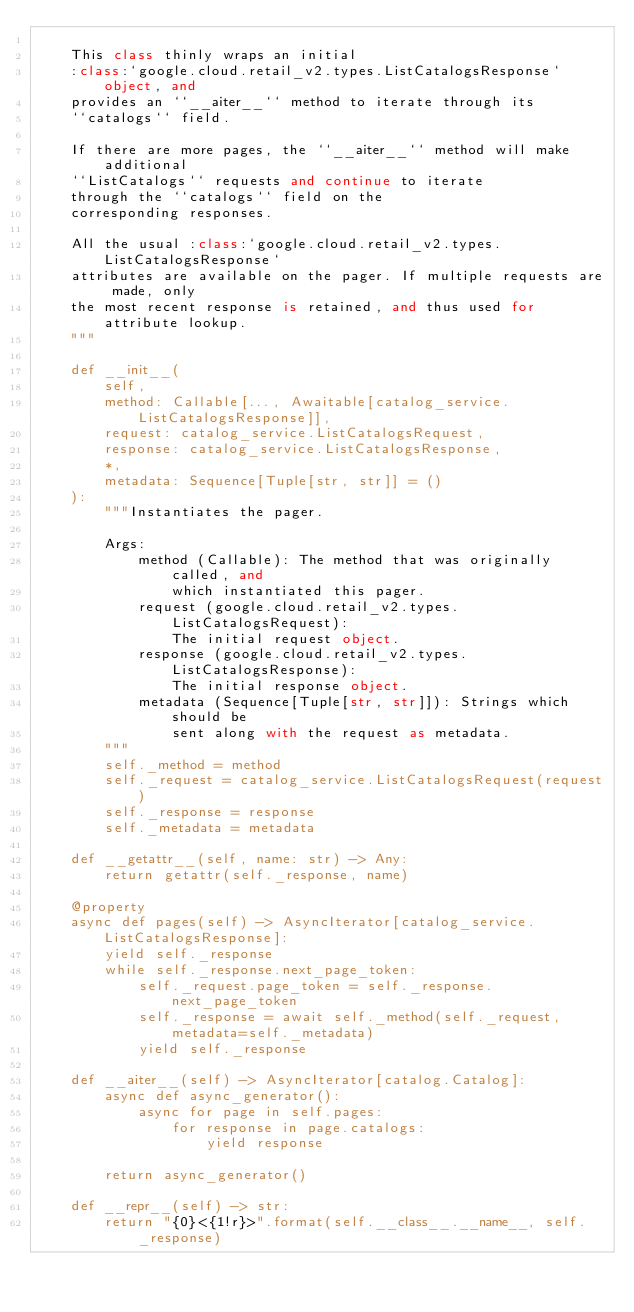<code> <loc_0><loc_0><loc_500><loc_500><_Python_>
    This class thinly wraps an initial
    :class:`google.cloud.retail_v2.types.ListCatalogsResponse` object, and
    provides an ``__aiter__`` method to iterate through its
    ``catalogs`` field.

    If there are more pages, the ``__aiter__`` method will make additional
    ``ListCatalogs`` requests and continue to iterate
    through the ``catalogs`` field on the
    corresponding responses.

    All the usual :class:`google.cloud.retail_v2.types.ListCatalogsResponse`
    attributes are available on the pager. If multiple requests are made, only
    the most recent response is retained, and thus used for attribute lookup.
    """

    def __init__(
        self,
        method: Callable[..., Awaitable[catalog_service.ListCatalogsResponse]],
        request: catalog_service.ListCatalogsRequest,
        response: catalog_service.ListCatalogsResponse,
        *,
        metadata: Sequence[Tuple[str, str]] = ()
    ):
        """Instantiates the pager.

        Args:
            method (Callable): The method that was originally called, and
                which instantiated this pager.
            request (google.cloud.retail_v2.types.ListCatalogsRequest):
                The initial request object.
            response (google.cloud.retail_v2.types.ListCatalogsResponse):
                The initial response object.
            metadata (Sequence[Tuple[str, str]]): Strings which should be
                sent along with the request as metadata.
        """
        self._method = method
        self._request = catalog_service.ListCatalogsRequest(request)
        self._response = response
        self._metadata = metadata

    def __getattr__(self, name: str) -> Any:
        return getattr(self._response, name)

    @property
    async def pages(self) -> AsyncIterator[catalog_service.ListCatalogsResponse]:
        yield self._response
        while self._response.next_page_token:
            self._request.page_token = self._response.next_page_token
            self._response = await self._method(self._request, metadata=self._metadata)
            yield self._response

    def __aiter__(self) -> AsyncIterator[catalog.Catalog]:
        async def async_generator():
            async for page in self.pages:
                for response in page.catalogs:
                    yield response

        return async_generator()

    def __repr__(self) -> str:
        return "{0}<{1!r}>".format(self.__class__.__name__, self._response)
</code> 